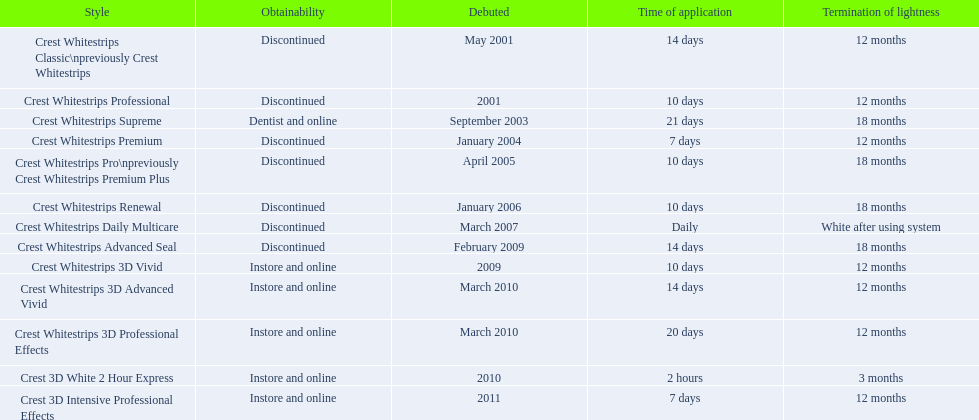What types of crest whitestrips have been released? Crest Whitestrips Classic\npreviously Crest Whitestrips, Crest Whitestrips Professional, Crest Whitestrips Supreme, Crest Whitestrips Premium, Crest Whitestrips Pro\npreviously Crest Whitestrips Premium Plus, Crest Whitestrips Renewal, Crest Whitestrips Daily Multicare, Crest Whitestrips Advanced Seal, Crest Whitestrips 3D Vivid, Crest Whitestrips 3D Advanced Vivid, Crest Whitestrips 3D Professional Effects, Crest 3D White 2 Hour Express, Crest 3D Intensive Professional Effects. What was the length of use for each type? 14 days, 10 days, 21 days, 7 days, 10 days, 10 days, Daily, 14 days, 10 days, 14 days, 20 days, 2 hours, 7 days. And how long did each last? 12 months, 12 months, 18 months, 12 months, 18 months, 18 months, White after using system, 18 months, 12 months, 12 months, 12 months, 3 months, 12 months. Of those models, which lasted the longest with the longest length of use? Crest Whitestrips Supreme. 